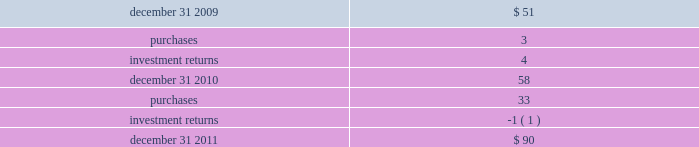Devon energy corporation and subsidiaries notes to consolidated financial statements 2014 ( continued ) the following methods and assumptions were used to estimate the fair values in the tables above .
Fixed-income securities 2014 devon 2019s fixed-income securities consist of u.s .
Treasury obligations , bonds issued by investment-grade companies from diverse industries , and asset-backed securities .
These fixed-income securities are actively traded securities that can be redeemed upon demand .
The fair values of these level 1 securities are based upon quoted market prices .
Devon 2019s fixed income securities also include commingled funds that primarily invest in long-term bonds and u.s .
Treasury securities .
These fixed income securities can be redeemed on demand but are not actively traded .
The fair values of these level 2 securities are based upon the net asset values provided by the investment managers .
Equity securities 2014 devon 2019s equity securities include a commingled global equity fund that invests in large , mid and small capitalization stocks across the world 2019s developed and emerging markets .
These equity securities can be redeemed on demand but are not actively traded .
The fair values of these level 2 securities are based upon the net asset values provided by the investment managers .
At december 31 , 2010 , devon 2019s equity securities consisted of investments in u.s .
Large and small capitalization companies and international large capitalization companies .
These equity securities were actively traded securities that could be redeemed upon demand .
The fair values of these level 1 securities are based upon quoted market prices .
At december 31 , 2010 , devon 2019s equity securities also included a commingled fund that invested in large capitalization companies .
These equity securities could be redeemed on demand but were not actively traded .
The fair values of these level 2 securities are based upon the net asset values provided by the investment managers .
Other securities 2014 devon 2019s other securities include commingled , short-term investment funds .
These securities can be redeemed on demand but are not actively traded .
The fair values of these level 2 securities are based upon the net asset values provided by investment managers .
Devon 2019s hedge fund and alternative investments include an investment in an actively traded global mutual fund that focuses on alternative investment strategies and a hedge fund of funds that invests both long and short using a variety of investment strategies .
Devon 2019s hedge fund of funds is not actively traded and devon is subject to redemption restrictions with regards to this investment .
The fair value of this level 3 investment represents the fair value as determined by the hedge fund manager .
Included below is a summary of the changes in devon 2019s level 3 plan assets ( in millions ) . .

What was the percentage change in devon 2019s level 3 plan assets from 2010 to 2011? 
Computations: ((90 - 58) / 58)
Answer: 0.55172. 